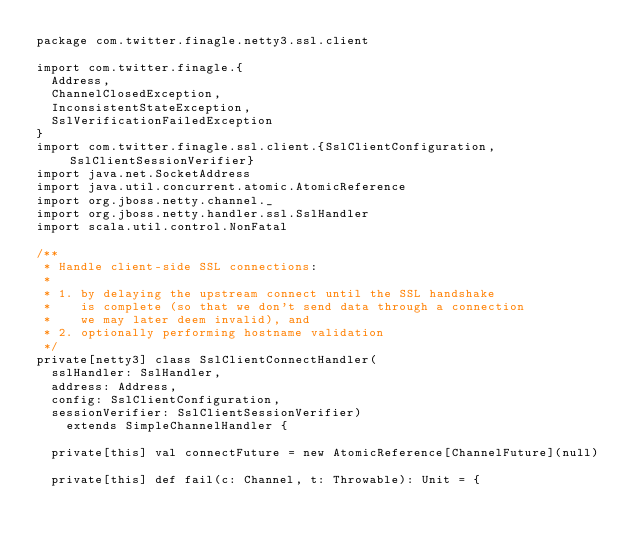Convert code to text. <code><loc_0><loc_0><loc_500><loc_500><_Scala_>package com.twitter.finagle.netty3.ssl.client

import com.twitter.finagle.{
  Address,
  ChannelClosedException,
  InconsistentStateException,
  SslVerificationFailedException
}
import com.twitter.finagle.ssl.client.{SslClientConfiguration, SslClientSessionVerifier}
import java.net.SocketAddress
import java.util.concurrent.atomic.AtomicReference
import org.jboss.netty.channel._
import org.jboss.netty.handler.ssl.SslHandler
import scala.util.control.NonFatal

/**
 * Handle client-side SSL connections:
 *
 * 1. by delaying the upstream connect until the SSL handshake
 *    is complete (so that we don't send data through a connection
 *    we may later deem invalid), and
 * 2. optionally performing hostname validation
 */
private[netty3] class SslClientConnectHandler(
  sslHandler: SslHandler,
  address: Address,
  config: SslClientConfiguration,
  sessionVerifier: SslClientSessionVerifier)
    extends SimpleChannelHandler {

  private[this] val connectFuture = new AtomicReference[ChannelFuture](null)

  private[this] def fail(c: Channel, t: Throwable): Unit = {</code> 